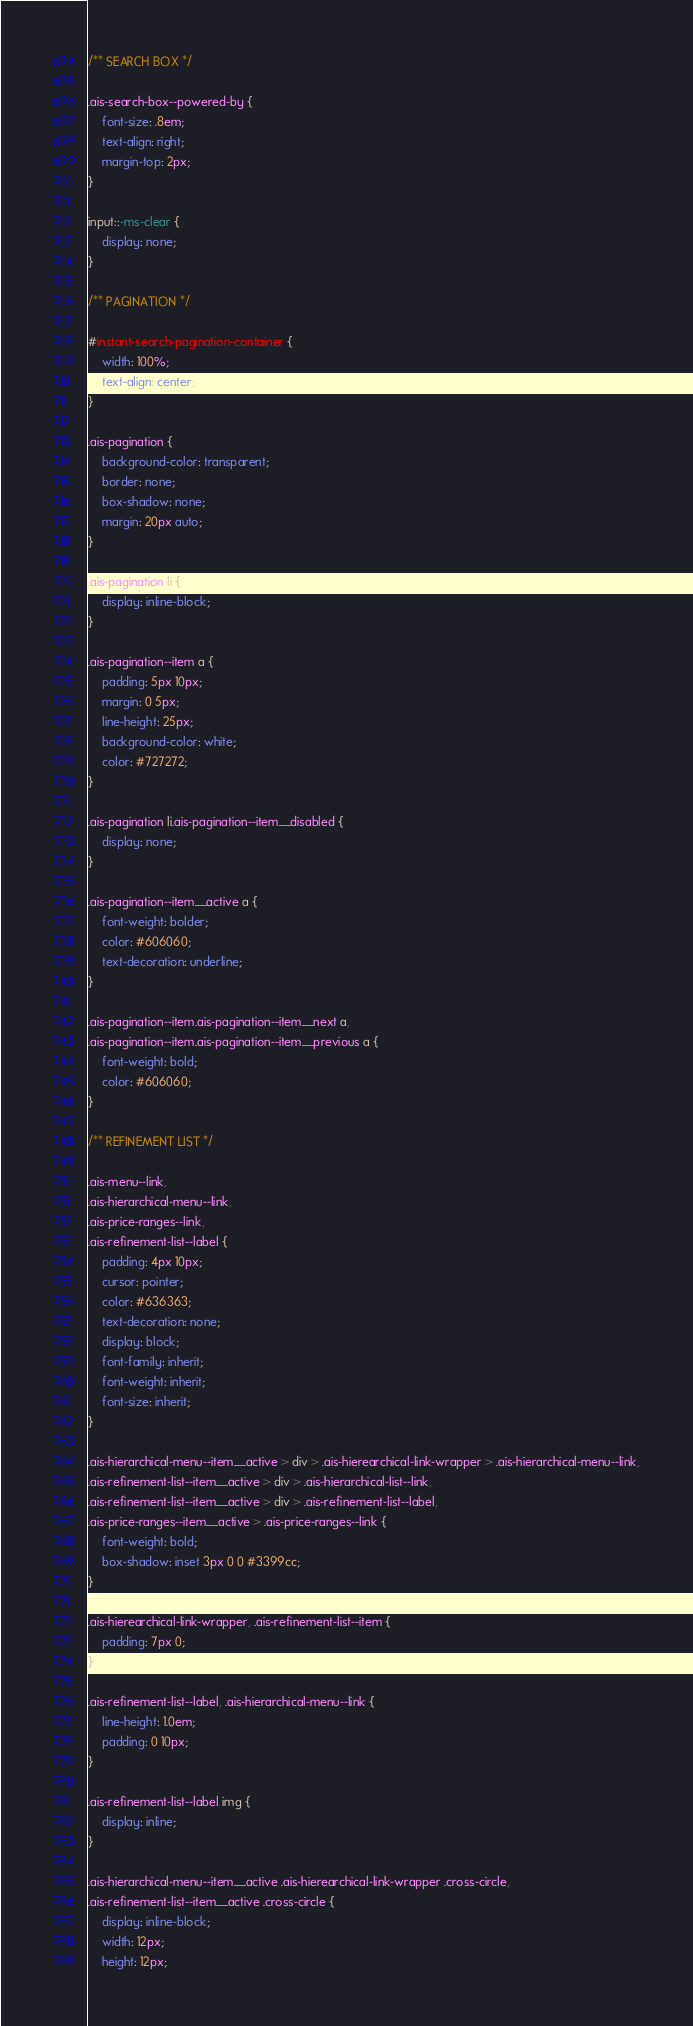Convert code to text. <code><loc_0><loc_0><loc_500><loc_500><_CSS_>/** SEARCH BOX */

.ais-search-box--powered-by {
    font-size: .8em;
    text-align: right;
    margin-top: 2px;
}

input::-ms-clear {
    display: none;
}

/** PAGINATION */

#instant-search-pagination-container {
    width: 100%;
    text-align: center;
}

.ais-pagination {
    background-color: transparent;
    border: none;
    box-shadow: none;
    margin: 20px auto;
}

.ais-pagination li {
    display: inline-block;
}

.ais-pagination--item a {
    padding: 5px 10px;
    margin: 0 5px;
    line-height: 25px;
    background-color: white;
    color: #727272;
}

.ais-pagination li.ais-pagination--item__disabled {
    display: none;
}

.ais-pagination--item__active a {
    font-weight: bolder;
    color: #606060;
    text-decoration: underline;
}

.ais-pagination--item.ais-pagination--item__next a,
.ais-pagination--item.ais-pagination--item__previous a {
    font-weight: bold;
    color: #606060;
}

/** REFINEMENT LIST */

.ais-menu--link,
.ais-hierarchical-menu--link,
.ais-price-ranges--link,
.ais-refinement-list--label {
    padding: 4px 10px;
    cursor: pointer;
    color: #636363;
    text-decoration: none;
    display: block;
    font-family: inherit;
    font-weight: inherit;
    font-size: inherit;
}

.ais-hierarchical-menu--item__active > div > .ais-hierearchical-link-wrapper > .ais-hierarchical-menu--link,
.ais-refinement-list--item__active > div > .ais-hierarchical-list--link,
.ais-refinement-list--item__active > div > .ais-refinement-list--label,
.ais-price-ranges--item__active > .ais-price-ranges--link {
    font-weight: bold;
    box-shadow: inset 3px 0 0 #3399cc;
}

.ais-hierearchical-link-wrapper, .ais-refinement-list--item {
    padding: 7px 0;
}

.ais-refinement-list--label, .ais-hierarchical-menu--link {
    line-height: 1.0em;
    padding: 0 10px;
}

.ais-refinement-list--label img {
    display: inline;
}

.ais-hierarchical-menu--item__active .ais-hierearchical-link-wrapper .cross-circle,
.ais-refinement-list--item__active .cross-circle {
    display: inline-block;
    width: 12px;
    height: 12px;</code> 